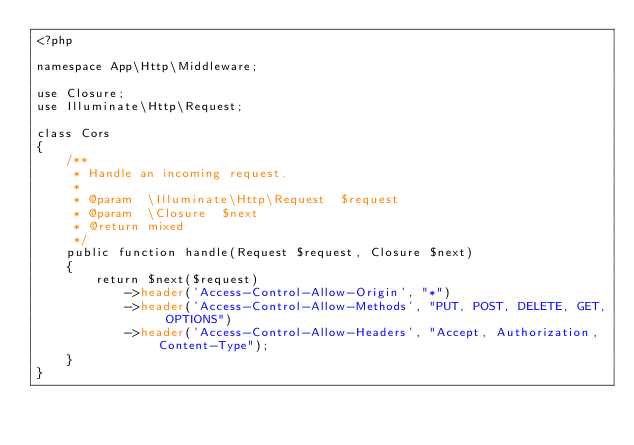<code> <loc_0><loc_0><loc_500><loc_500><_PHP_><?php

namespace App\Http\Middleware;

use Closure;
use Illuminate\Http\Request;

class Cors
{
    /**
     * Handle an incoming request.
     *
     * @param  \Illuminate\Http\Request  $request
     * @param  \Closure  $next
     * @return mixed
     */
    public function handle(Request $request, Closure $next)
    {
        return $next($request)
            ->header('Access-Control-Allow-Origin', "*")
            ->header('Access-Control-Allow-Methods', "PUT, POST, DELETE, GET, OPTIONS")
            ->header('Access-Control-Allow-Headers', "Accept, Authorization, Content-Type");
    }
}
</code> 